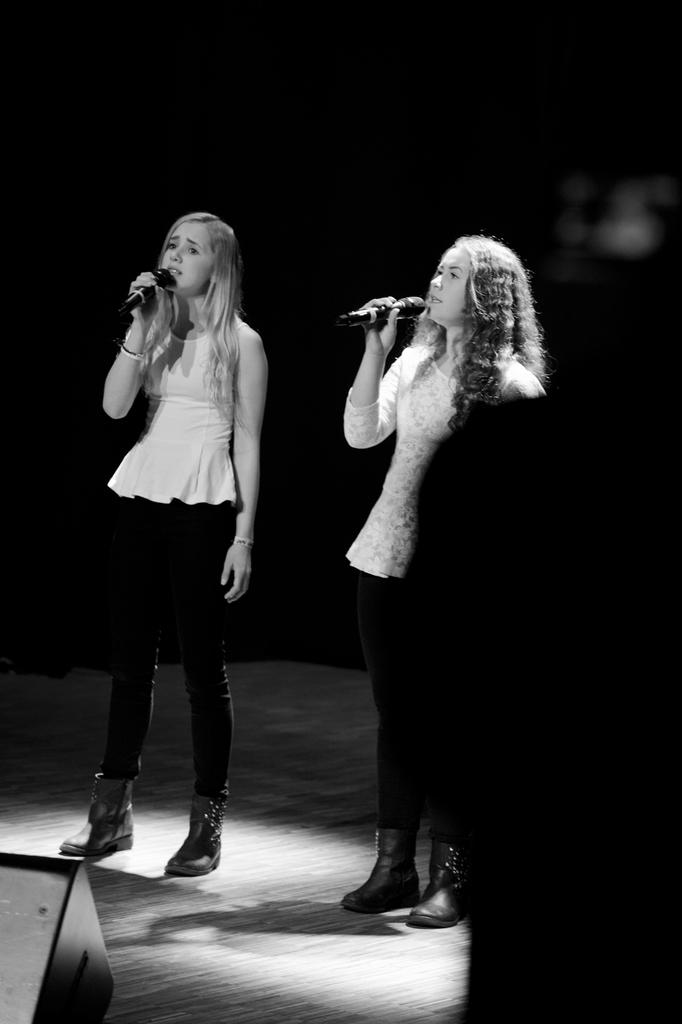How many people are in the image? There are two women in the image. What are the women doing in the image? Both women are standing and holding microphones. What is the color scheme of the image? The image is black and white in color. What type of disease is affecting the women in the image? There is no indication of any disease affecting the women in the image. Can you tell me how tall the giants are in the image? There are no giants present in the image; it features two women holding microphones. 